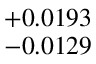<formula> <loc_0><loc_0><loc_500><loc_500>^ { + 0 . 0 1 9 3 } _ { - 0 . 0 1 2 9 }</formula> 